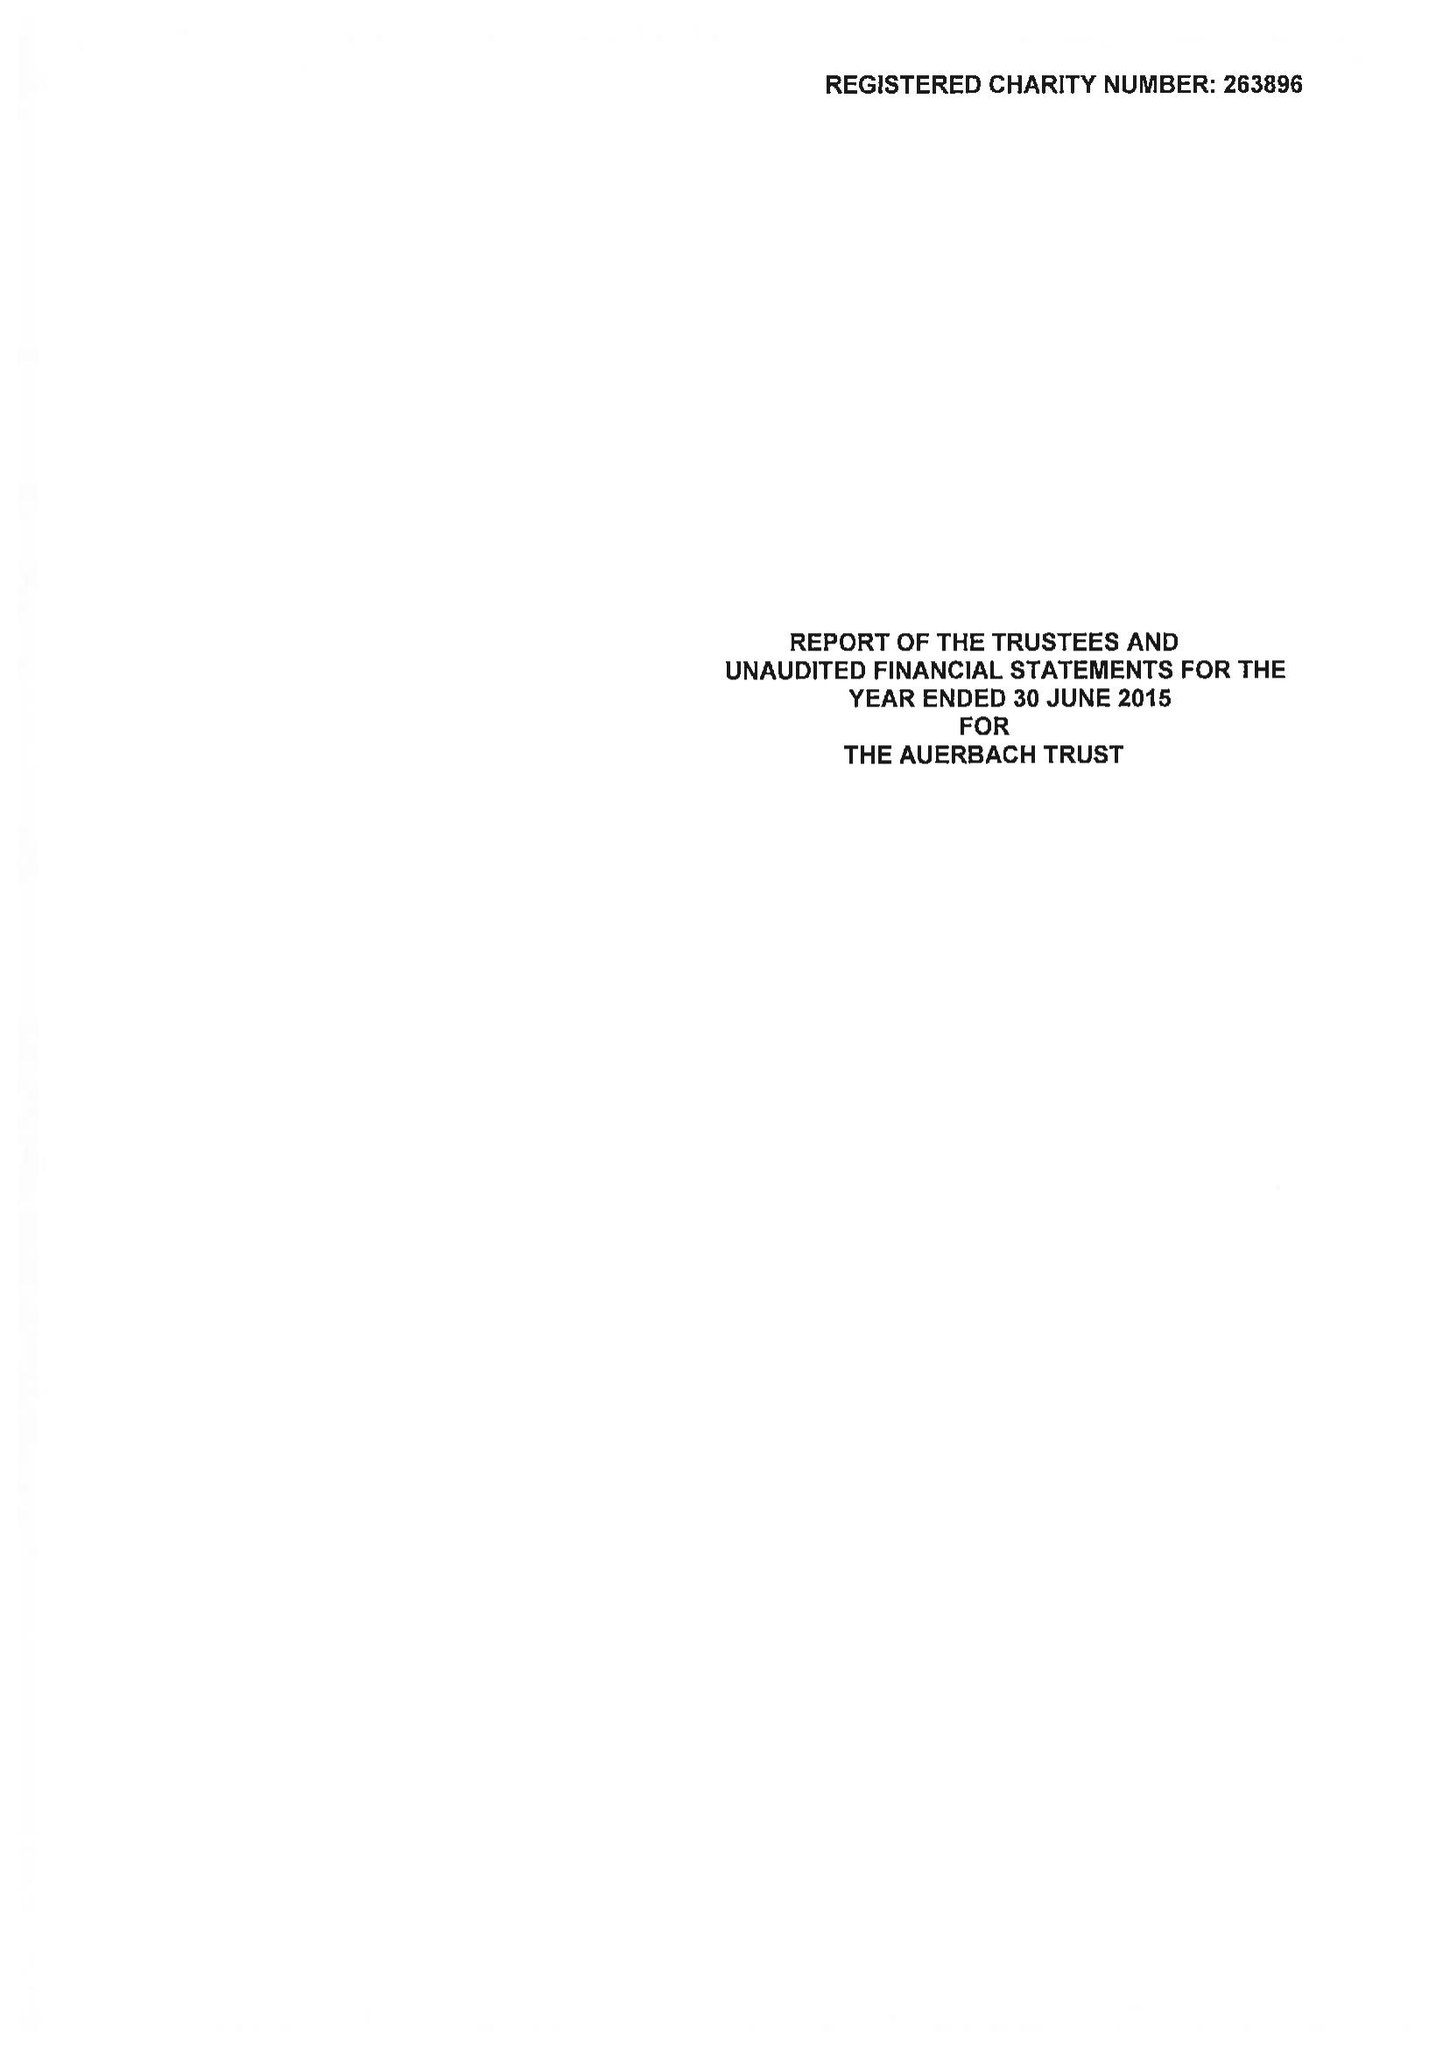What is the value for the address__postcode?
Answer the question using a single word or phrase. NW1 4RD 